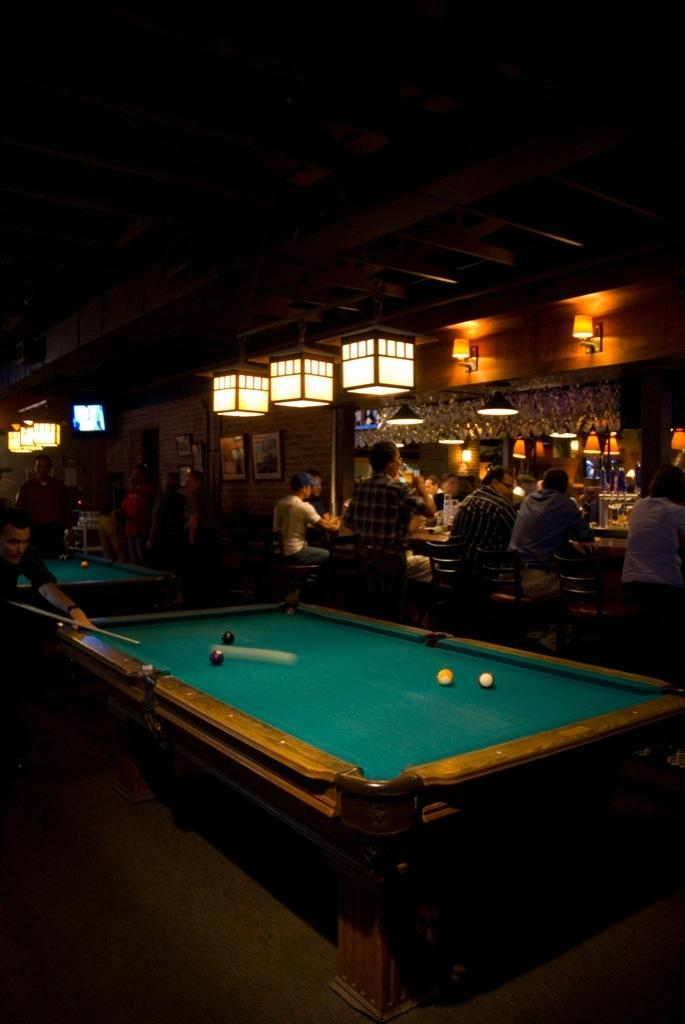What type of setting is depicted in the image? The image is an indoor setting. What are the people in the image doing? People are sitting on chairs in the image. What game is being played in the image? There is a snooker board with balls in the image, suggesting that the game being played is snooker. What type of lighting is present in the image? There are lights on top in the image. How many frogs are sitting on the snooker balls in the image? There are no frogs present in the image; it features a snooker board with balls and people sitting on chairs. 